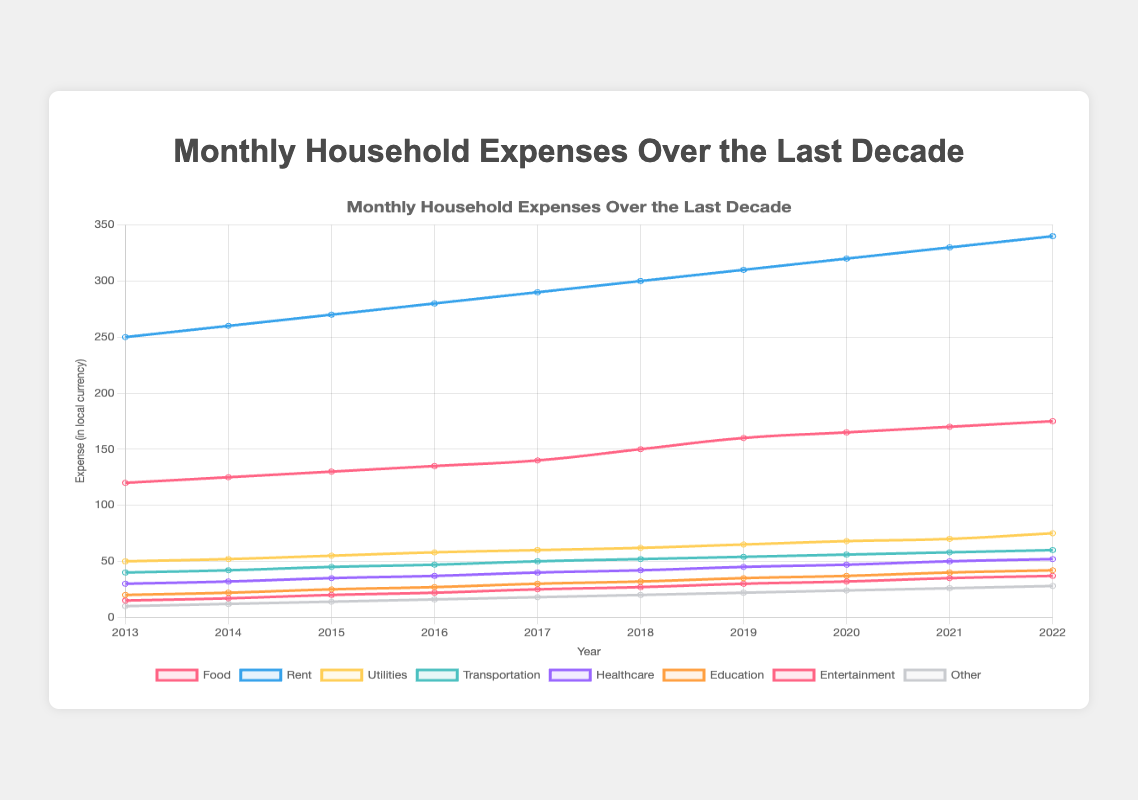what has been the trend in food expenses over the last decade? The trend in food expenses over the last decade shows a consistent increase, starting from 120 in 2013 and reaching 175 in 2022.
Answer: consistent increase which category had the highest monthly expense in 2018? The category with the highest monthly expense in 2018 is Rent, with a value of 300.
Answer: Rent how do healthcare expenses in 2022 compare to those in 2013? Healthcare expenses increased from 30 in 2013 to 52 in 2022.
Answer: increased what is the difference in education expenses between 2020 and 2022? Education expenses were 37 in 2020 and increased to 42 in 2022. The difference is 42 - 37 = 5.
Answer: 5 which category shows the most significant increase over the decade? To find the most significant increase, we can calculate the change for each category from 2013 to 2022. Rent increased by 340 - 250 = 90. Food increased by 175 - 120 = 55. ... (calculations continue). Rent shows the most significant increase of 90.
Answer: Rent what is the sum of transportation and utilities expenses in 2015? The transportation expenses in 2015 are 45, and utilities expenses are 55. The sum is 45 + 55 = 100.
Answer: 100 which three categories had the lowest expenses in 2017? The three lowest-expense categories in 2017 are Entertainment (25), Education (30), and Healthcare (40).
Answer: Entertainment, Education, Healthcare what is the average monthly expense for the food category over the decade? The average is calculated by summing all food expenses from 2013 to 2022 and then dividing by the number of years. Sum = 120 + 125 + 130 + ... + 175 = 1370. The average is 1370 / 10 = 137.
Answer: 137 what year did rent and utilities expenses differ the most? To find the year with the most significant difference, we calculate the difference for each year. Example for 2013: Rent (250) - Utilities (50) = 200. Comparing all years, 2022 shows the most significant difference of 340 - 75 = 265.
Answer: 2022 what was the total household monthly expense in 2021? The total expense in 2021 is the sum of all category expenses: 170 (Food) + 330 (Rent) + 70 (Utilities) + 58 (Transportation) + 50 (Healthcare) + 40 (Education) + 35 (Entertainment) + 26 (Other) = 779.
Answer: 779 